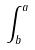Convert formula to latex. <formula><loc_0><loc_0><loc_500><loc_500>\int _ { b } ^ { a }</formula> 